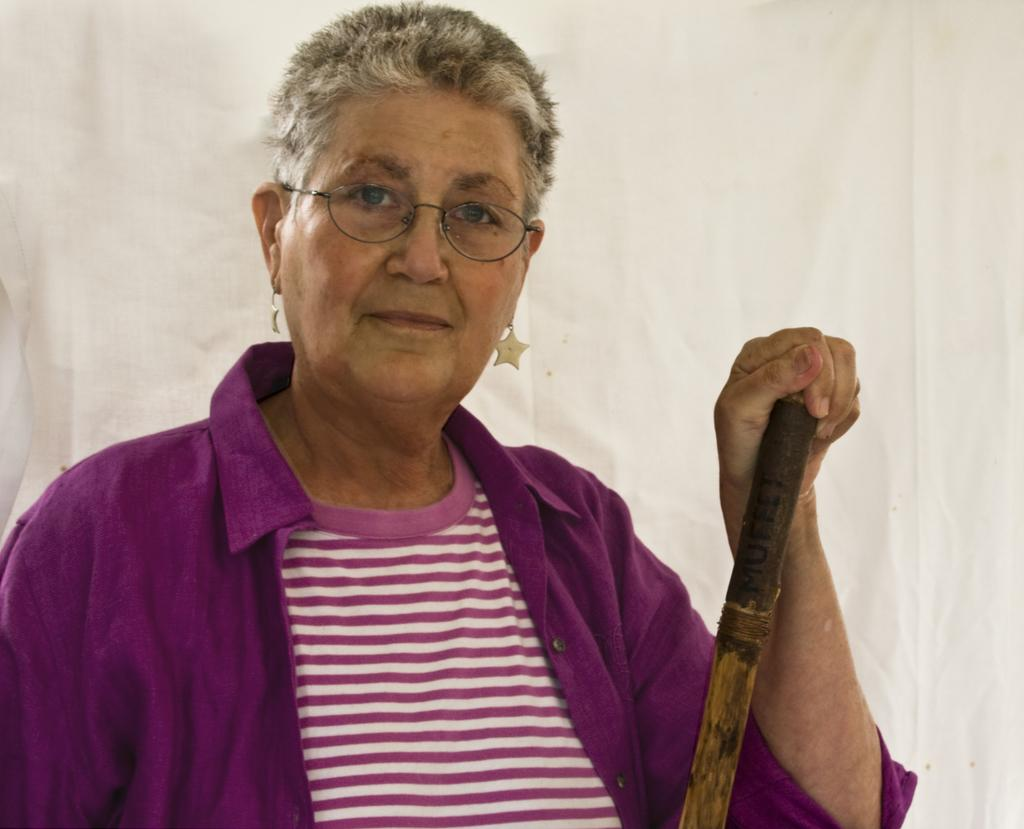Who is the main subject in the image? There is a lady in the image. What is the lady doing in the image? The lady is standing in the image. What object is the lady holding in the image? The lady is holding a stick in the image. What can be seen in the background of the image? There is a cloth in the background of the image. What type of prison can be seen in the image? There is no prison present in the image. How many fingers does the lady have on her left hand in the image? The image does not show the lady's fingers, so it cannot be determined how many fingers she has on her left hand. 